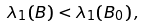Convert formula to latex. <formula><loc_0><loc_0><loc_500><loc_500>\lambda _ { 1 } ( B ) < \lambda _ { 1 } ( B _ { 0 } ) \, ,</formula> 